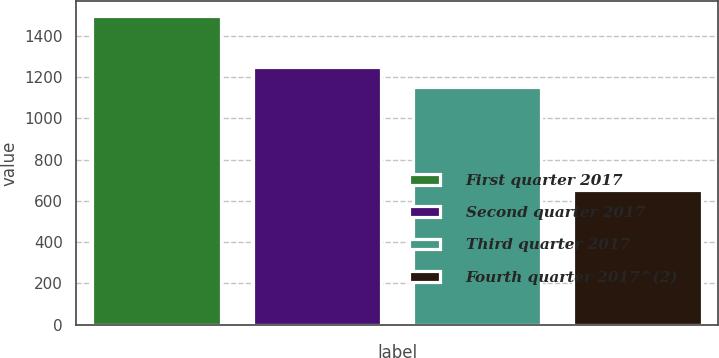Convert chart to OTSL. <chart><loc_0><loc_0><loc_500><loc_500><bar_chart><fcel>First quarter 2017<fcel>Second quarter 2017<fcel>Third quarter 2017<fcel>Fourth quarter 2017^(2)<nl><fcel>1493.4<fcel>1246.8<fcel>1150<fcel>652<nl></chart> 